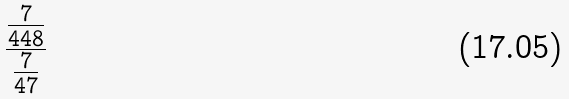Convert formula to latex. <formula><loc_0><loc_0><loc_500><loc_500>\frac { \frac { 7 } { 4 4 8 } } { \frac { 7 } { 4 7 } }</formula> 